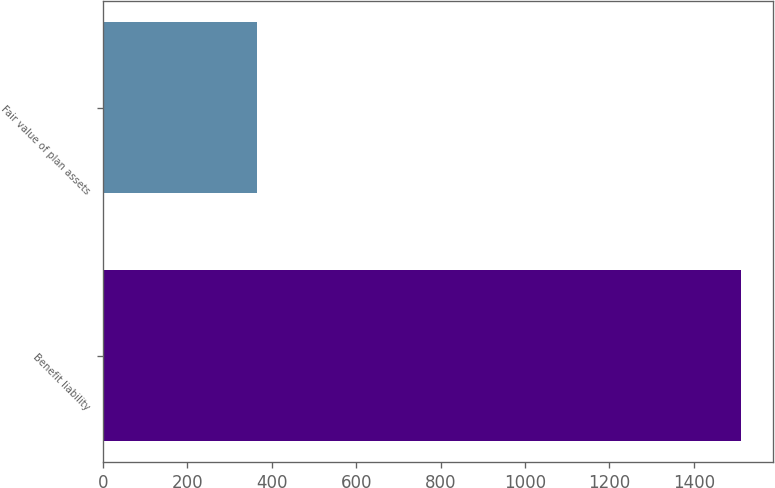Convert chart. <chart><loc_0><loc_0><loc_500><loc_500><bar_chart><fcel>Benefit liability<fcel>Fair value of plan assets<nl><fcel>1511<fcel>365<nl></chart> 